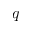Convert formula to latex. <formula><loc_0><loc_0><loc_500><loc_500>q</formula> 